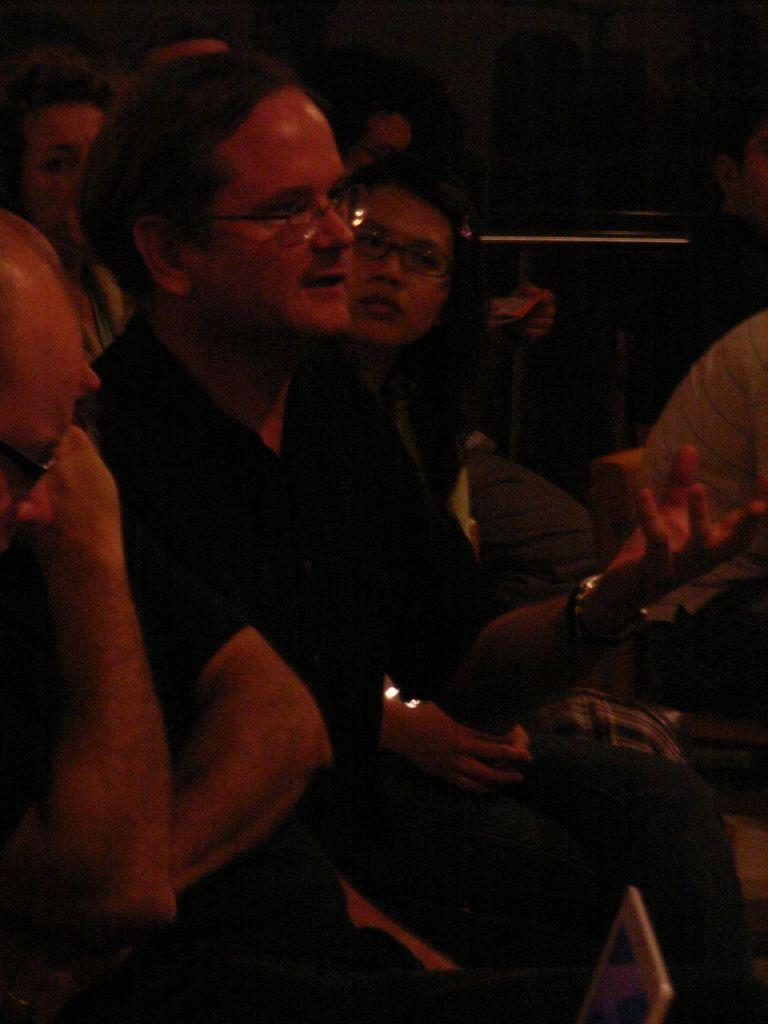What are the people in the image doing? The people in the image are sitting. What can be seen at the bottom of the image? There appears to be a laptop screen at the bottom of the image. What is the color of the background in the image? The background of the image is dark. What year is depicted in the image? The provided facts do not mention any specific year, so it cannot be determined from the image. What type of education is being pursued by the people in the image? There is no indication of any educational activity in the image, so it cannot be determined from the image. 